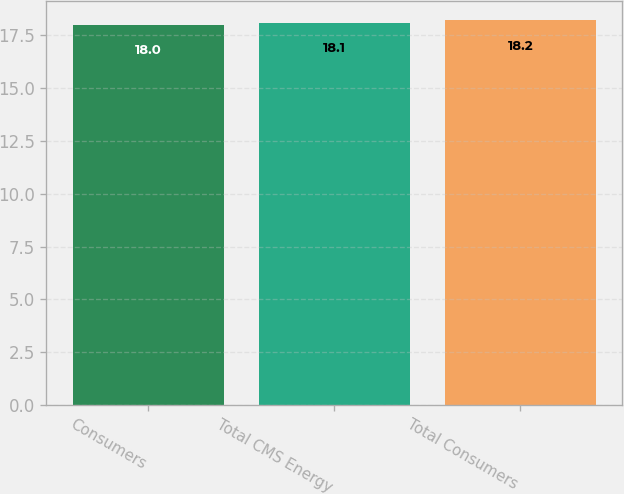<chart> <loc_0><loc_0><loc_500><loc_500><bar_chart><fcel>Consumers<fcel>Total CMS Energy<fcel>Total Consumers<nl><fcel>18<fcel>18.1<fcel>18.2<nl></chart> 